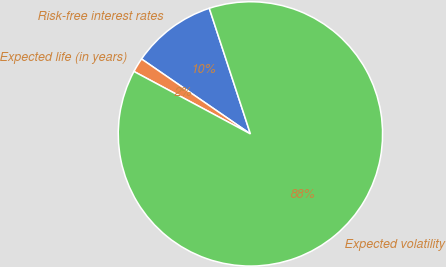Convert chart. <chart><loc_0><loc_0><loc_500><loc_500><pie_chart><fcel>Risk-free interest rates<fcel>Expected life (in years)<fcel>Expected volatility<nl><fcel>10.37%<fcel>1.76%<fcel>87.86%<nl></chart> 